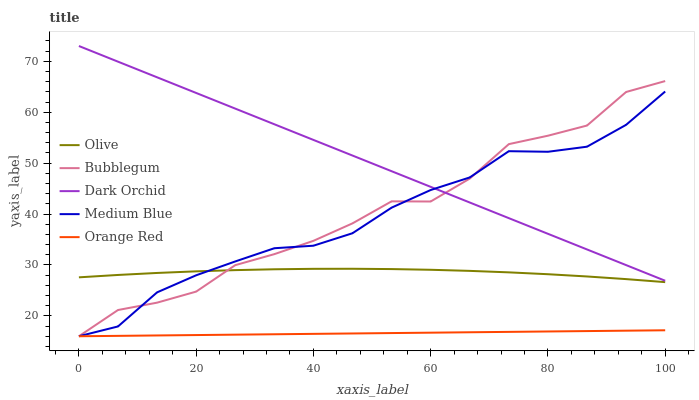Does Orange Red have the minimum area under the curve?
Answer yes or no. Yes. Does Dark Orchid have the maximum area under the curve?
Answer yes or no. Yes. Does Medium Blue have the minimum area under the curve?
Answer yes or no. No. Does Medium Blue have the maximum area under the curve?
Answer yes or no. No. Is Orange Red the smoothest?
Answer yes or no. Yes. Is Bubblegum the roughest?
Answer yes or no. Yes. Is Medium Blue the smoothest?
Answer yes or no. No. Is Medium Blue the roughest?
Answer yes or no. No. Does Medium Blue have the lowest value?
Answer yes or no. Yes. Does Dark Orchid have the lowest value?
Answer yes or no. No. Does Dark Orchid have the highest value?
Answer yes or no. Yes. Does Medium Blue have the highest value?
Answer yes or no. No. Is Orange Red less than Olive?
Answer yes or no. Yes. Is Dark Orchid greater than Orange Red?
Answer yes or no. Yes. Does Olive intersect Bubblegum?
Answer yes or no. Yes. Is Olive less than Bubblegum?
Answer yes or no. No. Is Olive greater than Bubblegum?
Answer yes or no. No. Does Orange Red intersect Olive?
Answer yes or no. No. 